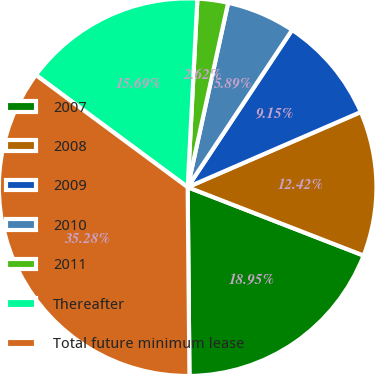Convert chart to OTSL. <chart><loc_0><loc_0><loc_500><loc_500><pie_chart><fcel>2007<fcel>2008<fcel>2009<fcel>2010<fcel>2011<fcel>Thereafter<fcel>Total future minimum lease<nl><fcel>18.95%<fcel>12.42%<fcel>9.15%<fcel>5.89%<fcel>2.62%<fcel>15.69%<fcel>35.28%<nl></chart> 